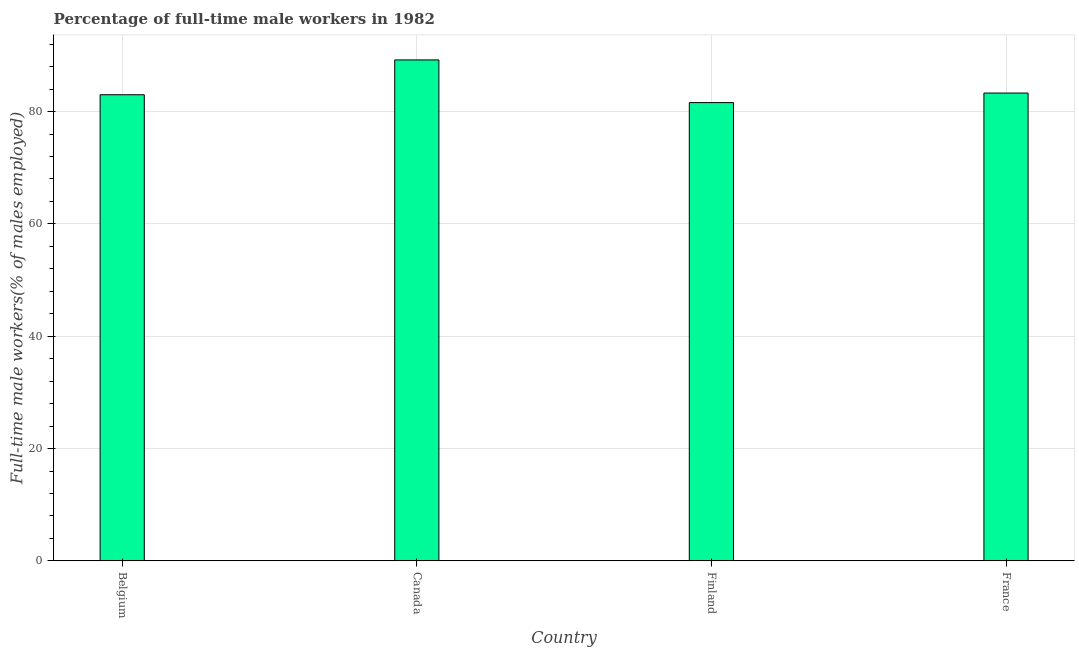Does the graph contain any zero values?
Your answer should be very brief. No. Does the graph contain grids?
Give a very brief answer. Yes. What is the title of the graph?
Provide a short and direct response. Percentage of full-time male workers in 1982. What is the label or title of the Y-axis?
Offer a terse response. Full-time male workers(% of males employed). What is the percentage of full-time male workers in Canada?
Provide a succinct answer. 89.2. Across all countries, what is the maximum percentage of full-time male workers?
Offer a terse response. 89.2. Across all countries, what is the minimum percentage of full-time male workers?
Provide a succinct answer. 81.6. What is the sum of the percentage of full-time male workers?
Your answer should be very brief. 337.1. What is the average percentage of full-time male workers per country?
Offer a very short reply. 84.28. What is the median percentage of full-time male workers?
Give a very brief answer. 83.15. In how many countries, is the percentage of full-time male workers greater than 72 %?
Keep it short and to the point. 4. Is the percentage of full-time male workers in Canada less than that in Finland?
Make the answer very short. No. How many bars are there?
Offer a very short reply. 4. How many countries are there in the graph?
Keep it short and to the point. 4. Are the values on the major ticks of Y-axis written in scientific E-notation?
Offer a very short reply. No. What is the Full-time male workers(% of males employed) of Belgium?
Keep it short and to the point. 83. What is the Full-time male workers(% of males employed) of Canada?
Make the answer very short. 89.2. What is the Full-time male workers(% of males employed) of Finland?
Keep it short and to the point. 81.6. What is the Full-time male workers(% of males employed) in France?
Provide a succinct answer. 83.3. What is the difference between the Full-time male workers(% of males employed) in Canada and France?
Offer a terse response. 5.9. What is the ratio of the Full-time male workers(% of males employed) in Belgium to that in Finland?
Your answer should be very brief. 1.02. What is the ratio of the Full-time male workers(% of males employed) in Belgium to that in France?
Your response must be concise. 1. What is the ratio of the Full-time male workers(% of males employed) in Canada to that in Finland?
Give a very brief answer. 1.09. What is the ratio of the Full-time male workers(% of males employed) in Canada to that in France?
Keep it short and to the point. 1.07. 